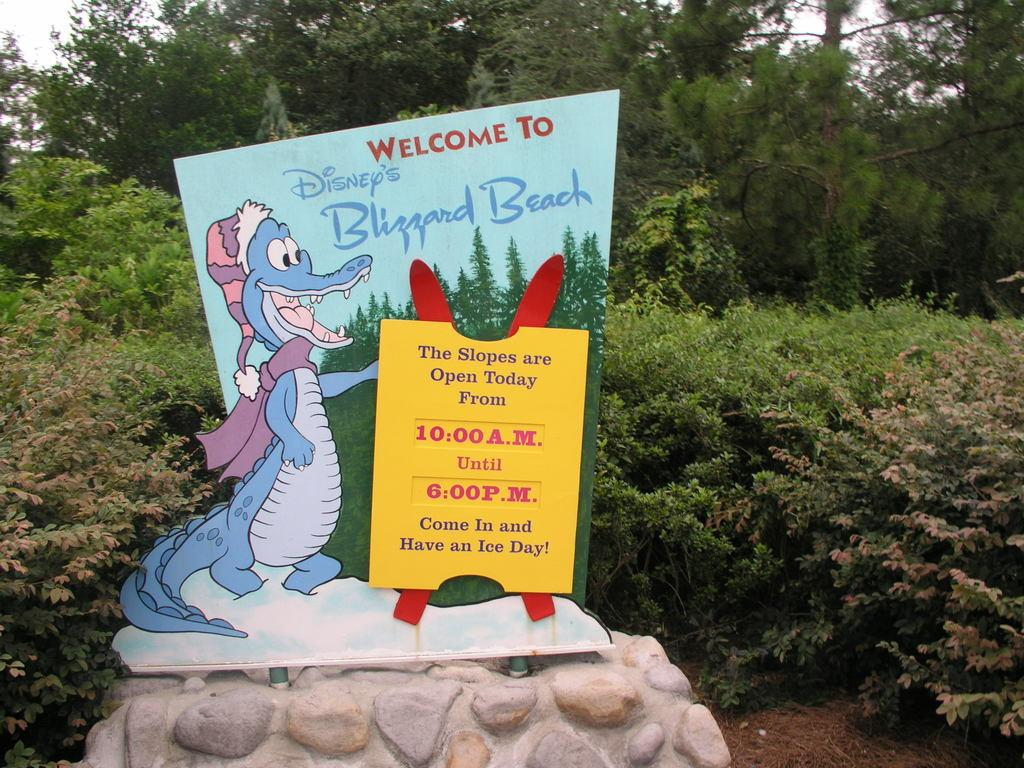What is the main object in the image? There is a rock in the image. What else can be seen in the image besides the rock? There is a banner, plants, trees, and the sky visible in the image. Can you describe the banner in the image? The banner is a separate object from the rock, but its details are not mentioned in the facts. What type of vegetation is present in the image? There are plants and trees in the image. What is visible at the top of the image? The sky is visible at the top of the image. How does the rock contribute to pollution in the image? The rock does not contribute to pollution in the image, as rocks are not a source of pollution. 